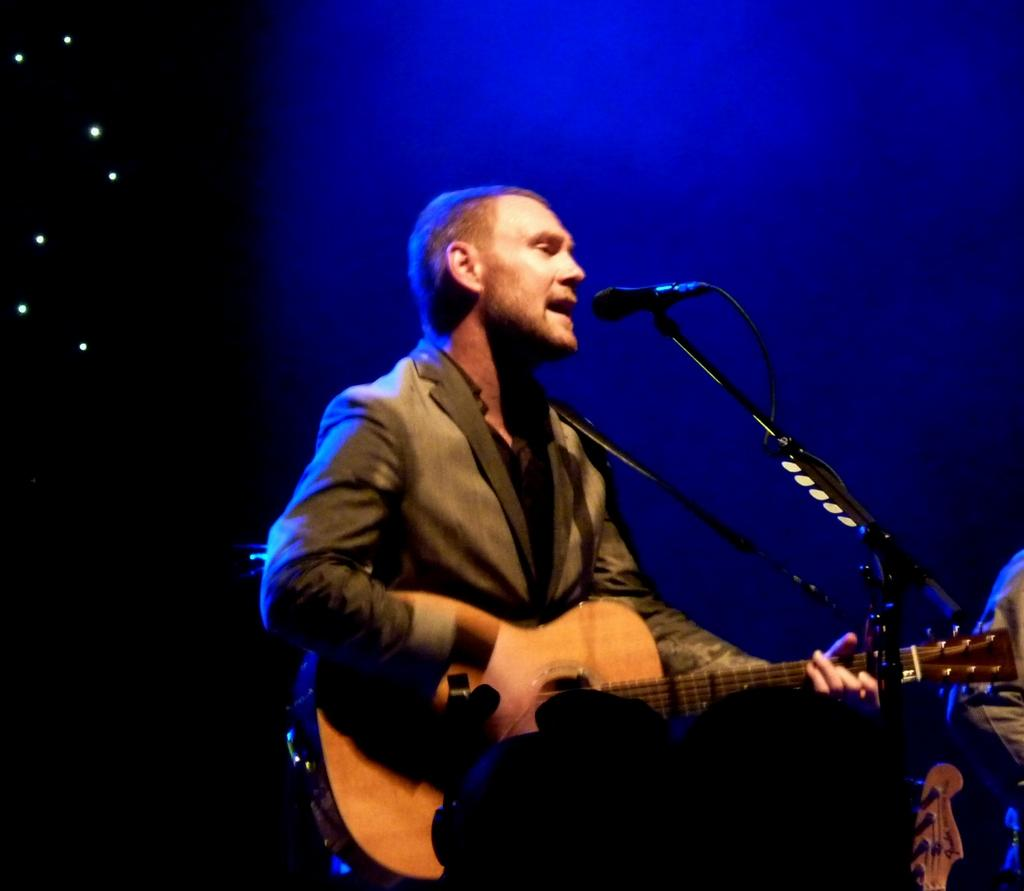Who is the main subject in the image? There is a man in the image. What is the man doing in the image? The man is standing in front of a microphone and playing a guitar. What can be seen in the background of the image? There are lights visible in the background of the image. What type of pin is the man wearing on his shirt in the image? There is no pin visible on the man's shirt in the image. How does the kite fly in the image? There is no kite present in the image. 